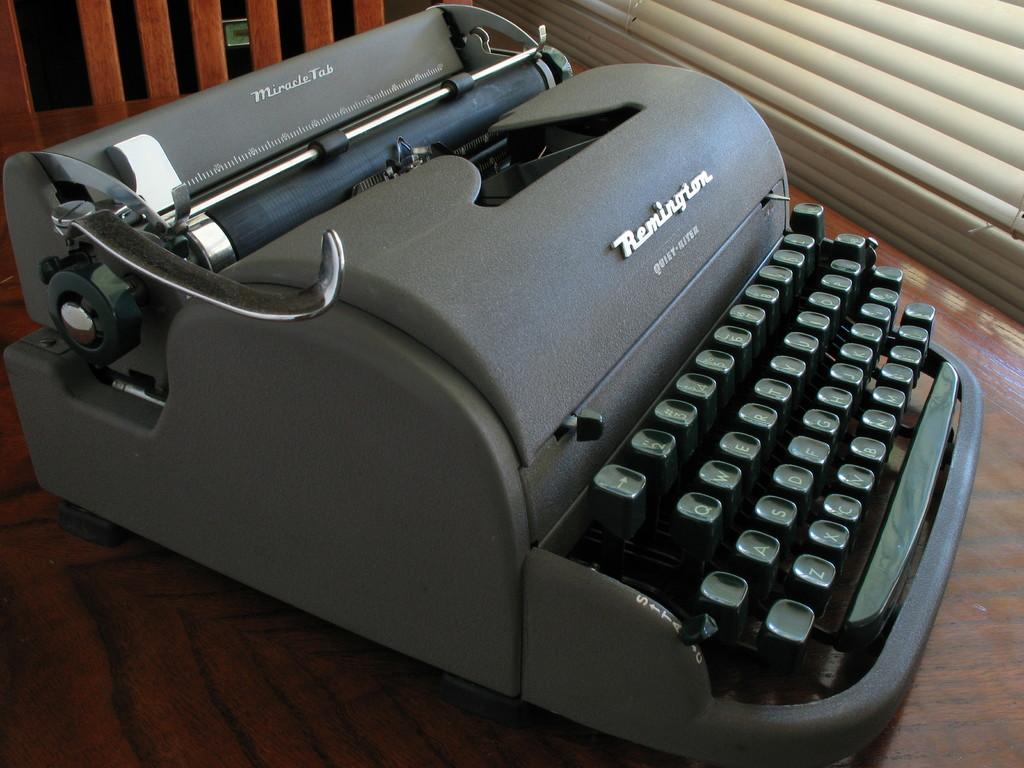What type of typewriter is this?
Ensure brevity in your answer.  Remington. Is there a q on the keys?
Ensure brevity in your answer.  Yes. 